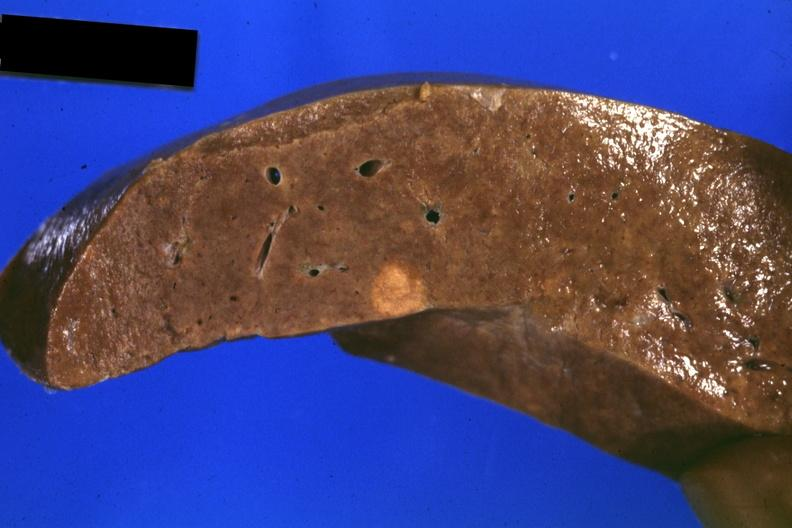s hepatobiliary present?
Answer the question using a single word or phrase. Yes 